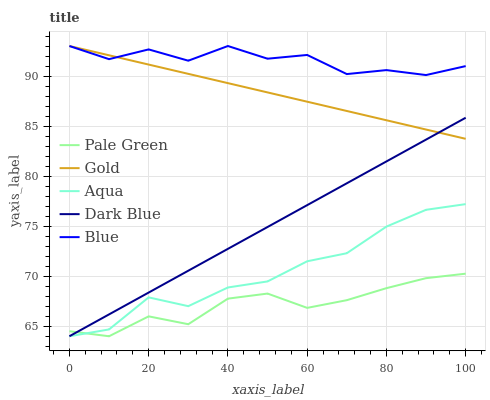Does Pale Green have the minimum area under the curve?
Answer yes or no. Yes. Does Dark Blue have the minimum area under the curve?
Answer yes or no. No. Does Dark Blue have the maximum area under the curve?
Answer yes or no. No. Is Pale Green the smoothest?
Answer yes or no. No. Is Pale Green the roughest?
Answer yes or no. No. Does Gold have the lowest value?
Answer yes or no. No. Does Dark Blue have the highest value?
Answer yes or no. No. Is Aqua less than Blue?
Answer yes or no. Yes. Is Blue greater than Dark Blue?
Answer yes or no. Yes. Does Aqua intersect Blue?
Answer yes or no. No. 